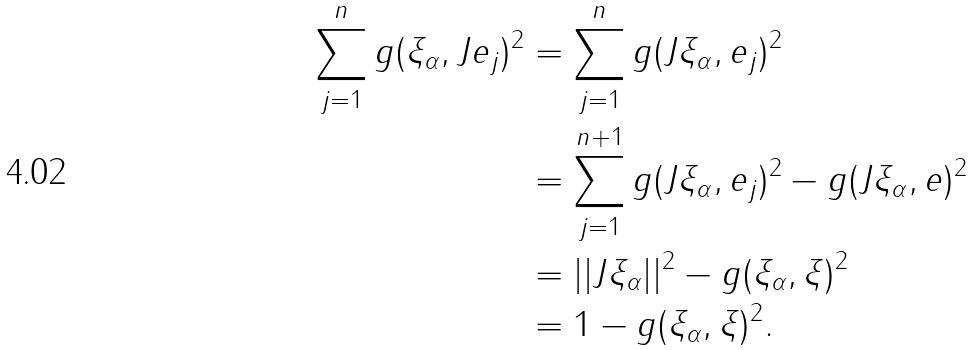<formula> <loc_0><loc_0><loc_500><loc_500>\sum _ { j = 1 } ^ { n } g ( \xi _ { \alpha } , J e _ { j } ) ^ { 2 } & = \sum _ { j = 1 } ^ { n } g ( J \xi _ { \alpha } , e _ { j } ) ^ { 2 } \\ & = \sum _ { j = 1 } ^ { n + 1 } g ( J \xi _ { \alpha } , e _ { j } ) ^ { 2 } - g ( J \xi _ { \alpha } , e ) ^ { 2 } \\ & = | | J \xi _ { \alpha } | | ^ { 2 } - g ( \xi _ { \alpha } , \xi ) ^ { 2 } \\ & = 1 - g ( \xi _ { \alpha } , \xi ) ^ { 2 } .</formula> 